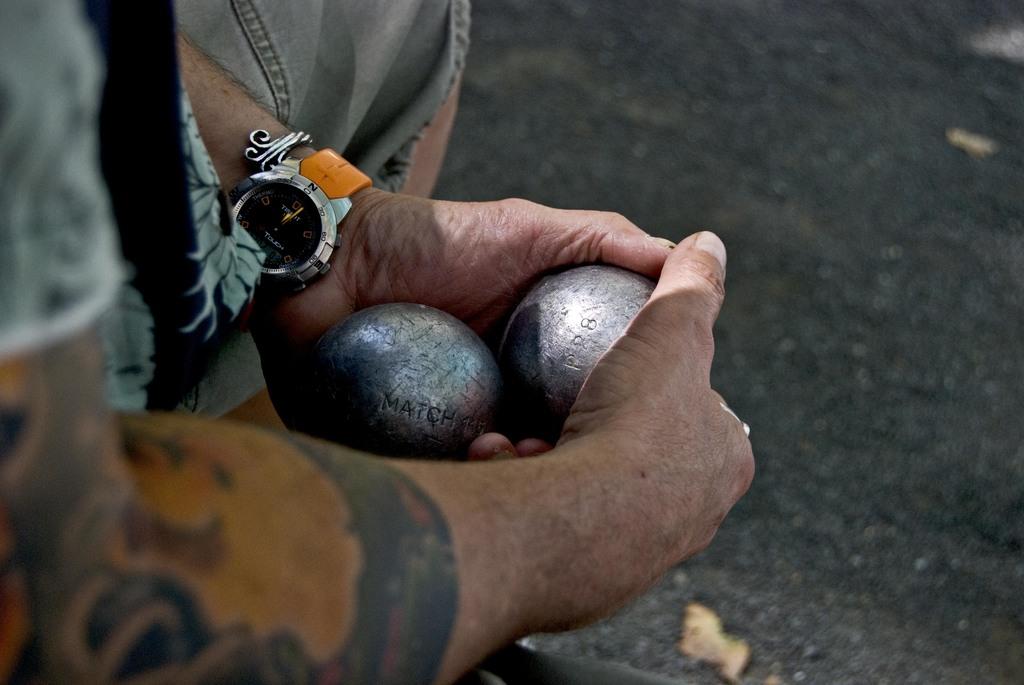What is written on both of these balls?
Give a very brief answer. Match. 